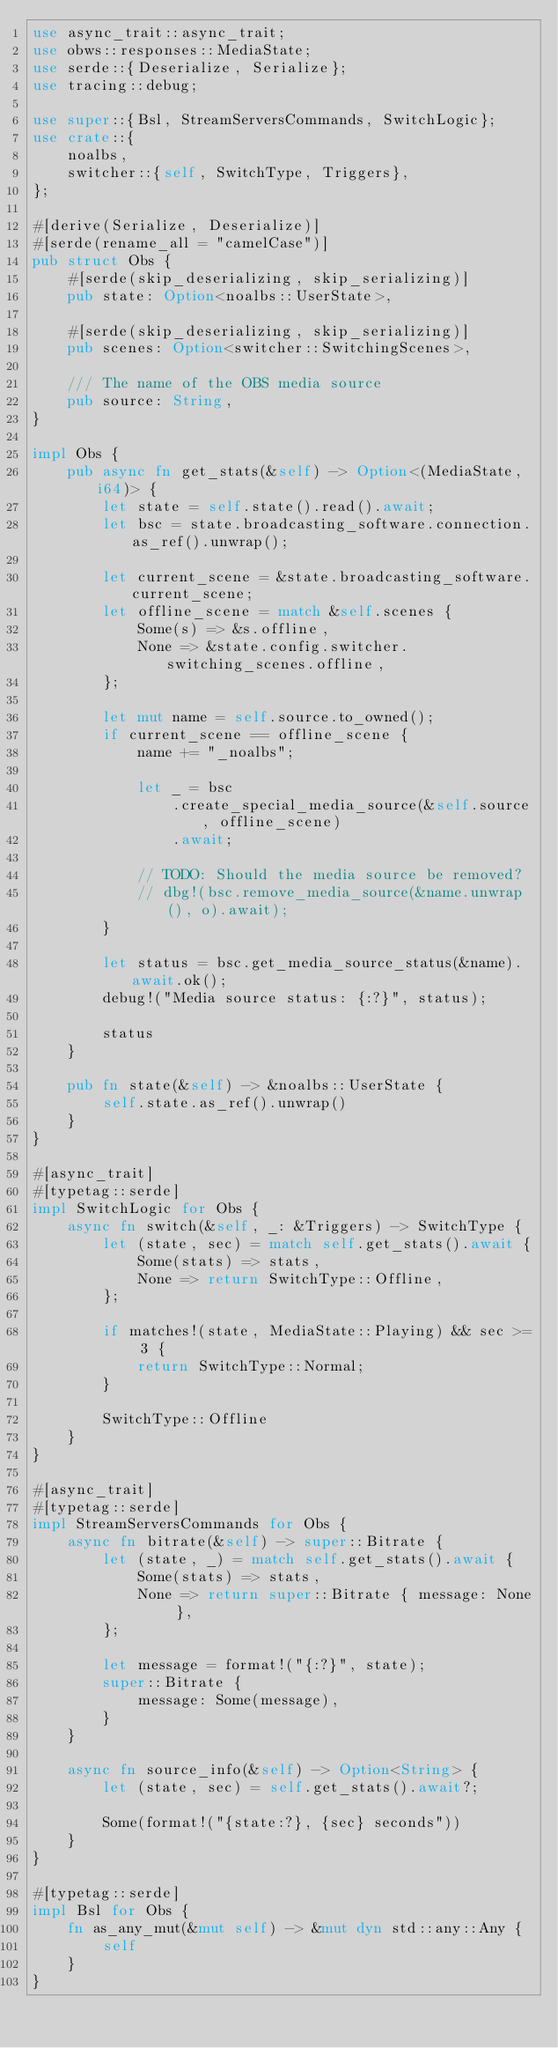Convert code to text. <code><loc_0><loc_0><loc_500><loc_500><_Rust_>use async_trait::async_trait;
use obws::responses::MediaState;
use serde::{Deserialize, Serialize};
use tracing::debug;

use super::{Bsl, StreamServersCommands, SwitchLogic};
use crate::{
    noalbs,
    switcher::{self, SwitchType, Triggers},
};

#[derive(Serialize, Deserialize)]
#[serde(rename_all = "camelCase")]
pub struct Obs {
    #[serde(skip_deserializing, skip_serializing)]
    pub state: Option<noalbs::UserState>,

    #[serde(skip_deserializing, skip_serializing)]
    pub scenes: Option<switcher::SwitchingScenes>,

    /// The name of the OBS media source
    pub source: String,
}

impl Obs {
    pub async fn get_stats(&self) -> Option<(MediaState, i64)> {
        let state = self.state().read().await;
        let bsc = state.broadcasting_software.connection.as_ref().unwrap();

        let current_scene = &state.broadcasting_software.current_scene;
        let offline_scene = match &self.scenes {
            Some(s) => &s.offline,
            None => &state.config.switcher.switching_scenes.offline,
        };

        let mut name = self.source.to_owned();
        if current_scene == offline_scene {
            name += "_noalbs";

            let _ = bsc
                .create_special_media_source(&self.source, offline_scene)
                .await;

            // TODO: Should the media source be removed?
            // dbg!(bsc.remove_media_source(&name.unwrap(), o).await);
        }

        let status = bsc.get_media_source_status(&name).await.ok();
        debug!("Media source status: {:?}", status);

        status
    }

    pub fn state(&self) -> &noalbs::UserState {
        self.state.as_ref().unwrap()
    }
}

#[async_trait]
#[typetag::serde]
impl SwitchLogic for Obs {
    async fn switch(&self, _: &Triggers) -> SwitchType {
        let (state, sec) = match self.get_stats().await {
            Some(stats) => stats,
            None => return SwitchType::Offline,
        };

        if matches!(state, MediaState::Playing) && sec >= 3 {
            return SwitchType::Normal;
        }

        SwitchType::Offline
    }
}

#[async_trait]
#[typetag::serde]
impl StreamServersCommands for Obs {
    async fn bitrate(&self) -> super::Bitrate {
        let (state, _) = match self.get_stats().await {
            Some(stats) => stats,
            None => return super::Bitrate { message: None },
        };

        let message = format!("{:?}", state);
        super::Bitrate {
            message: Some(message),
        }
    }

    async fn source_info(&self) -> Option<String> {
        let (state, sec) = self.get_stats().await?;

        Some(format!("{state:?}, {sec} seconds"))
    }
}

#[typetag::serde]
impl Bsl for Obs {
    fn as_any_mut(&mut self) -> &mut dyn std::any::Any {
        self
    }
}
</code> 